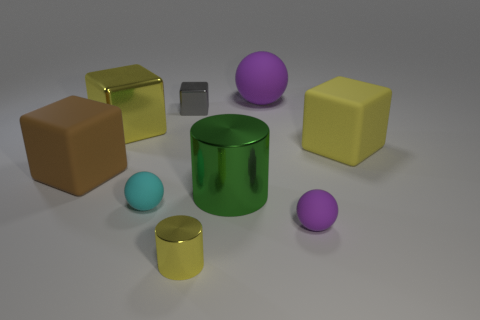There is a tiny shiny object that is the same color as the large shiny block; what is its shape?
Offer a terse response. Cylinder. There is a cyan thing that is the same shape as the large purple rubber thing; what is it made of?
Ensure brevity in your answer.  Rubber. Do the matte cube that is behind the brown thing and the small cyan matte sphere have the same size?
Offer a very short reply. No. What is the color of the block that is both right of the big brown matte cube and on the left side of the cyan thing?
Offer a terse response. Yellow. There is a matte cube to the left of the tiny metal cube; how many yellow shiny blocks are in front of it?
Offer a terse response. 0. Is the gray metallic thing the same shape as the large brown matte thing?
Your answer should be compact. Yes. Are there any other things that are the same color as the small shiny block?
Offer a terse response. No. Does the large yellow rubber thing have the same shape as the large shiny thing to the left of the yellow metal cylinder?
Your response must be concise. Yes. What is the color of the small sphere on the right side of the small thing that is in front of the purple matte ball in front of the green object?
Provide a short and direct response. Purple. Is there any other thing that is made of the same material as the small cyan ball?
Give a very brief answer. Yes. 